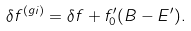Convert formula to latex. <formula><loc_0><loc_0><loc_500><loc_500>\delta f ^ { ( g i ) } = \delta f + f _ { 0 } ^ { \prime } ( B - E ^ { \prime } ) .</formula> 